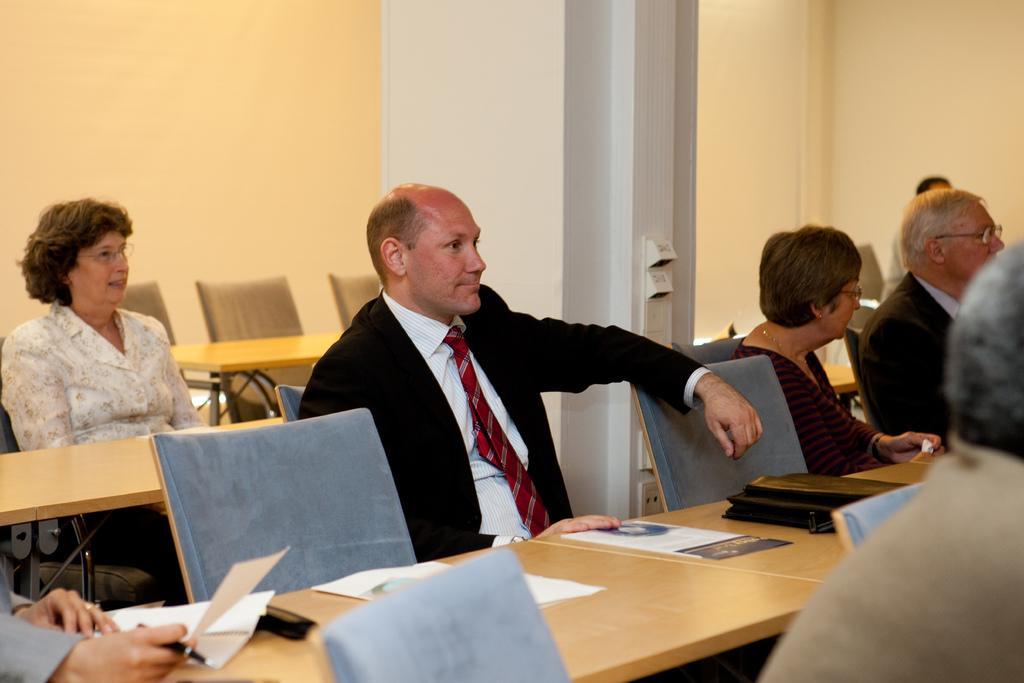In one or two sentences, can you explain what this image depicts? In this Image I can see few people are sitting on chairs. I can also see one of them is wearing formal dress and few of them are wearing specs. I can also see few more chairs, tables and on this tables I can see few white colour papers. 